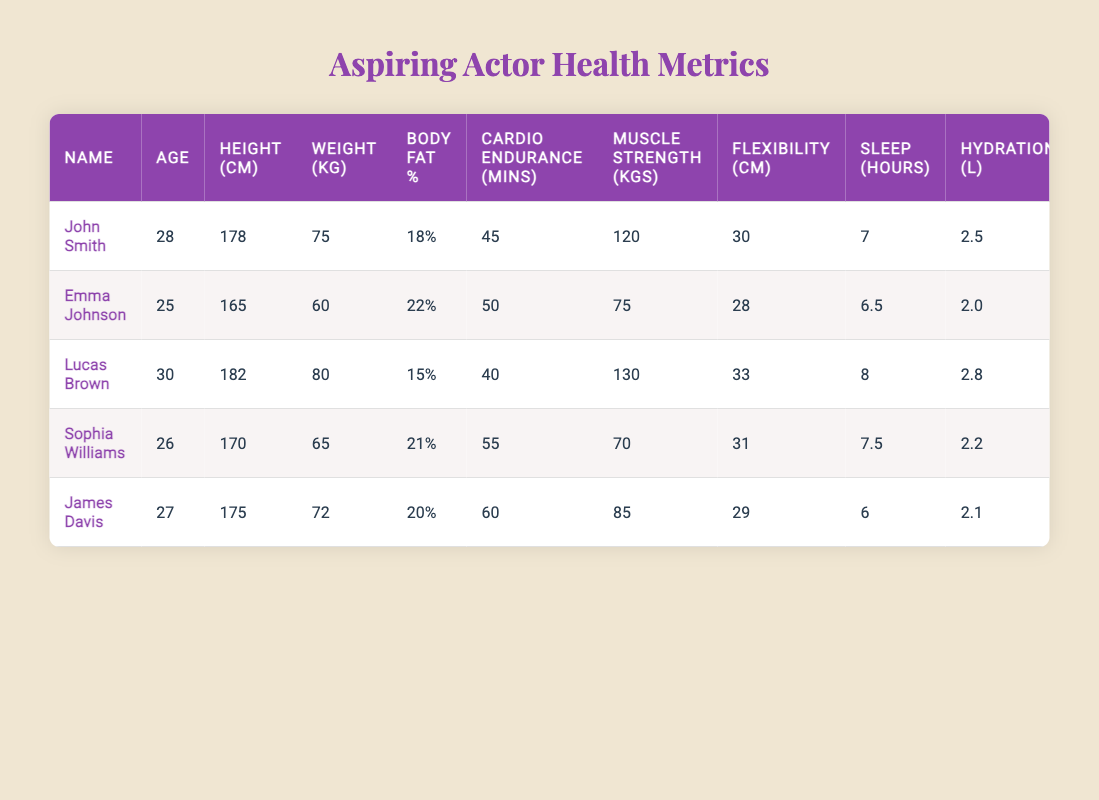What is the age of Lucas Brown? The table shows that Lucas Brown's age is listed under the "Age" column. The data points show that Lucas's age is 30.
Answer: 30 Which actor has the highest muscle strength? By examining the "Muscle Strength (kgs)" column, the values are 120 (John Smith), 75 (Emma Johnson), 130 (Lucas Brown), 70 (Sophia Williams), and 85 (James Davis). Lucas Brown has the highest value at 130 kgs.
Answer: Lucas Brown What is the average body fat percentage of the actors? To find the average body fat percentage, add the percentages: 18 + 22 + 15 + 21 + 20 = 96, then divide by the number of actors (5), which gives 96 / 5 = 19.2%.
Answer: 19.2% Is Emma Johnson older than James Davis? The ages are 25 (Emma Johnson) and 27 (James Davis). Since 25 is less than 27, Emma Johnson is not older than James Davis.
Answer: No Who is the youngest actor listed? The ages in the table are 28 (John Smith), 25 (Emma Johnson), 30 (Lucas Brown), 26 (Sophia Williams), and 27 (James Davis). The lowest age is 25, which belongs to Emma Johnson, making her the youngest.
Answer: Emma Johnson What is the hydration level of Sophia Williams? Sophia Williams' hydration level is found in the "Hydration (L)" column, where her value is recorded as 2.2 liters.
Answer: 2.2 What is the total cardio endurance (in minutes) of all actors combined? The cardio endurance values are 45, 50, 40, 55, and 60 minutes respectively. Adding these gives 45 + 50 + 40 + 55 + 60 = 250 minutes of total cardio endurance.
Answer: 250 Does anyone sleep less than 6 hours? The sleep hours listed are 7 (John Smith), 6.5 (Emma Johnson), 8 (Lucas Brown), 7.5 (Sophia Williams), and 6 (James Davis). Since James Davis sleeps exactly 6 hours, the statement is partly true; he does qualify.
Answer: Yes Who has the best flexibility test score? Flexibility test scores are 30 (John Smith), 28 (Emma Johnson), 33 (Lucas Brown), 31 (Sophia Williams), and 29 (James Davis). The highest score is 33, from Lucas Brown.
Answer: Lucas Brown 